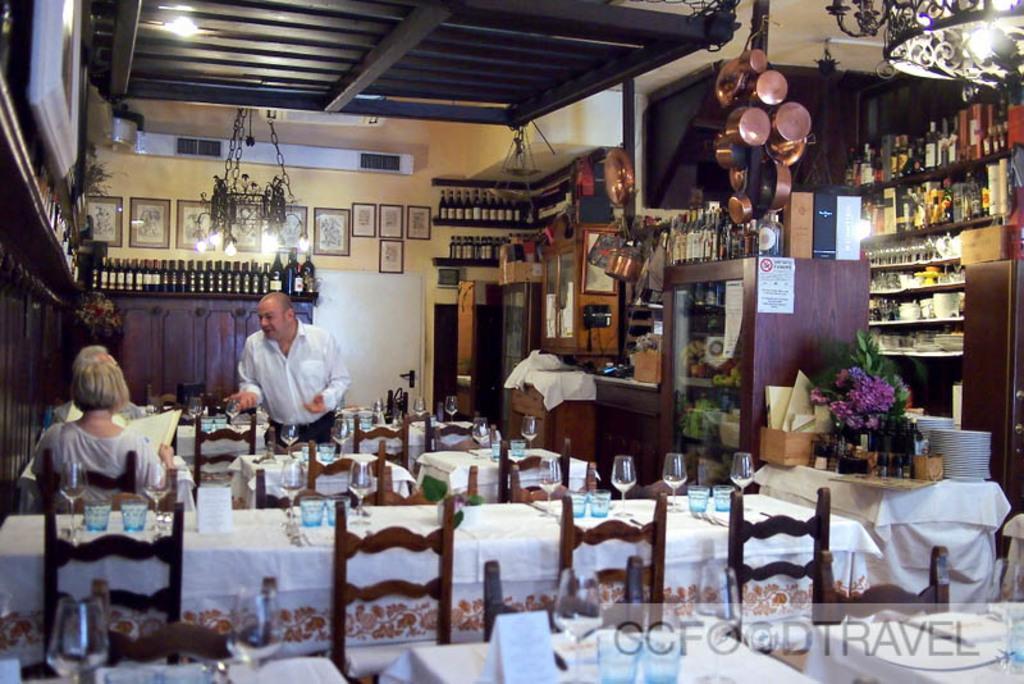How would you summarize this image in a sentence or two? In the image we can see there are people who are sitting on chair and in front of them there is a table, another man is standing at back on the wardrobe there are lot of wine bottles kept. 